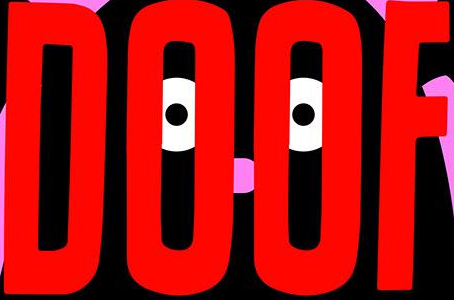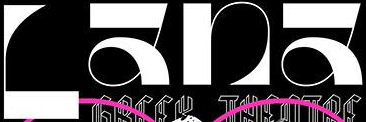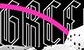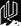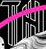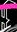Transcribe the words shown in these images in order, separated by a semicolon. DOOF; Lana; GRCC; #; TH; # 